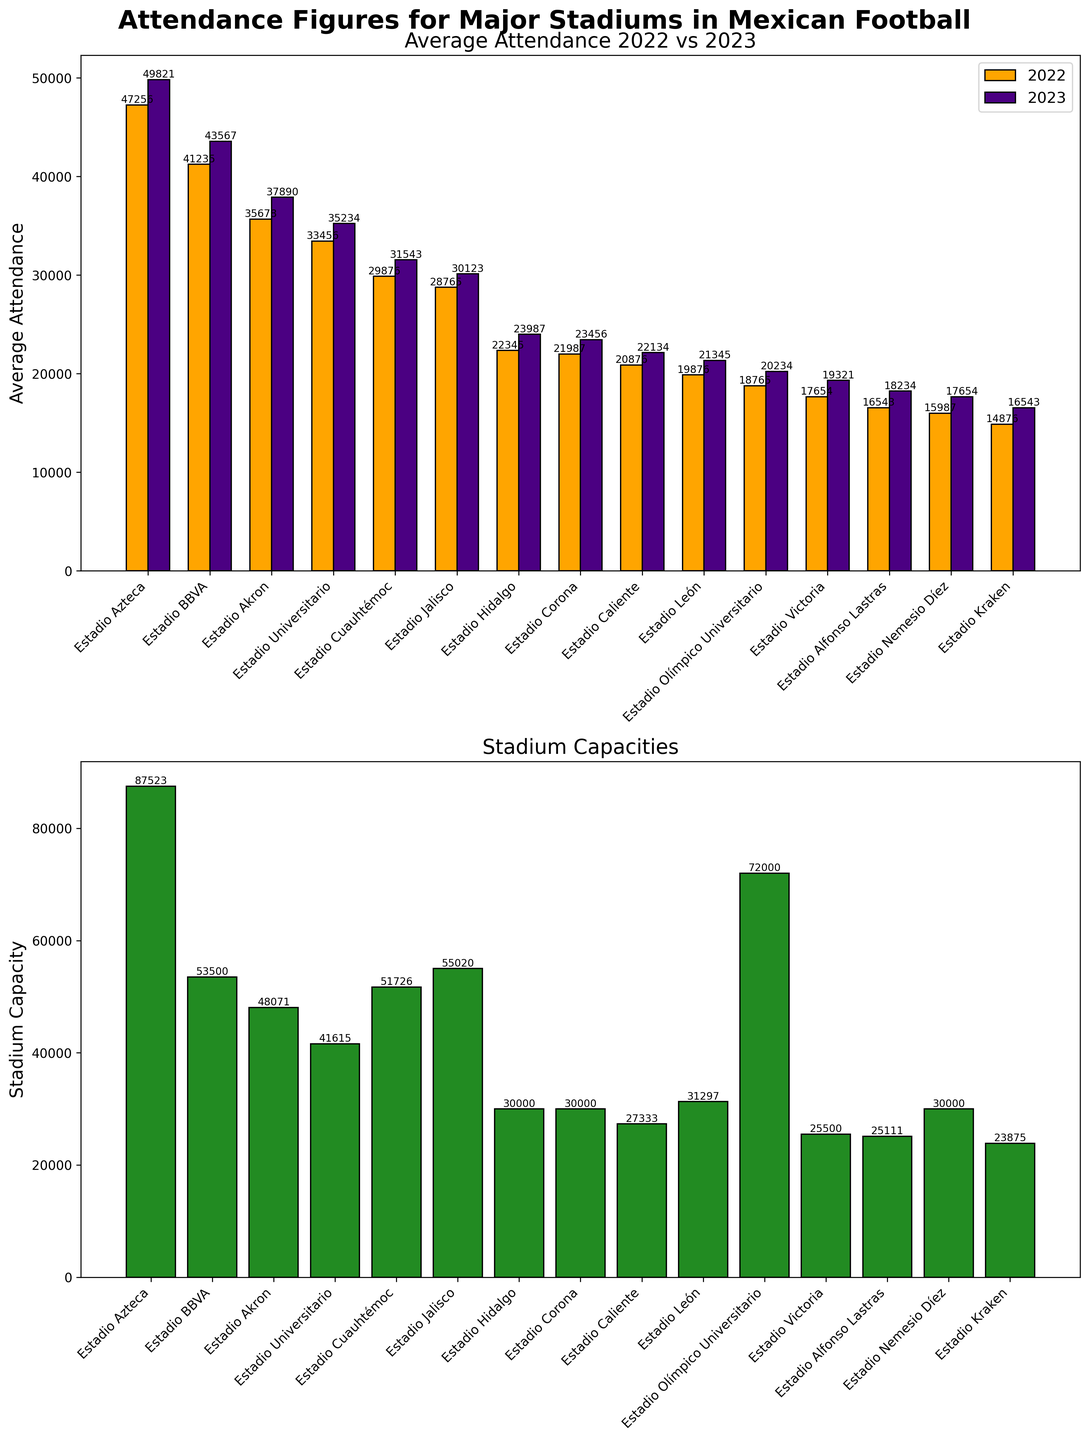Which stadium had the highest average attendance in 2023? By looking at the bar chart for average attendance in 2023 in the first subplot, the tallest bar represents the stadium with the highest attendance, which is Estadio Azteca.
Answer: Estadio Azteca How did the average attendance at Estadio BBVA change from 2022 to 2023? To find out the change, look at the heights of the bars for Estadio BBVA in both 2022 and 2023. The 2022 attendance is 41235, and the 2023 attendance is 43567, showing an increase.
Answer: Increased Which stadium has the largest capacity? Check the bar heights in the second subplot which represent stadium capacities. The tallest bar indicates Estadio Azteca, having the largest capacity.
Answer: Estadio Azteca How does the average attendance at Estadio Kraken in 2023 compare to Estadio Victoria? The bars in the 2023 average attendance subplot for Estadio Kraken and Estadio Victoria need to be compared. Estadio Kraken has 16543, and Estadio Victoria has 19321, indicating that Estadio Victoria's attendance is higher.
Answer: Estadio Victoria What is the difference between the stadium capacity of Estadio Jalisco and Estadio León? Identify the bar heights in the second subplot for Estadio Jalisco and Estadio León. Estadio Jalisco's capacity is 55020 and Estadio León's capacity is 31297. The difference is 55020 - 31297 = 23723.
Answer: 23723 How many stadiums have a capacity greater than 50000? Count the bars in the second subplot that exceed the 50000 mark on the y-axis. The qualifying stadiums are Estadio Azteca, Estadio BBVA, and Estadio Jalisco. So, there are 3 stadiums.
Answer: 3 Which stadium had the most significant increase in average attendance from 2022 to 2023? To find this, compare the height of each pair of bars in the first subplot for both years, subtracting 2022 values from 2023 values and determining the largest difference. Estadio BBVA has an increase of 43567 - 41235 = 2332, which is the largest observed.
Answer: Estadio BBVA Is the capacity of Estadio Cuauhtémoc greater than its average attendance in 2023? Compare the height of the bar representing Estadio Cuauhtémoc's capacity in the second subplot with its 2023 attendance in the first subplot. Estadio Cuauhtémoc's capacity is 51726, and its 2023 attendance is 31543. Yes, the capacity is greater.
Answer: Yes Which stadiums had an average attendance of less than 20000 in 2022? By looking at the lowest bars in the 2022 average attendance subplot, the stadiums with attendance below 20000 are Estadio Olímpico Universitario, Estadio Victoria, Estadio Alfonso Lastras, Estadio Nemesio Díez, and Estadio Kraken.
Answer: Estadio Olímpico Universitario, Estadio Victoria, Estadio Alfonso Lastras, Estadio Nemesio Díez, Estadio Kraken What's the average capacity of all the stadiums listed? Sum the capacities given for all stadiums and divide by the number of stadiums. The sum is 87523 + 53500 + 48071 + 41615 + 51726 + 55020 + 30000 + 30000 + 27333 + 31297 + 72000 + 25500 + 25111 + 30000 + 23875 = 642571. Dividing by 15 stadiums, the average capacity is 642571 / 15 ≈ 42838.07.
Answer: 42838.07 